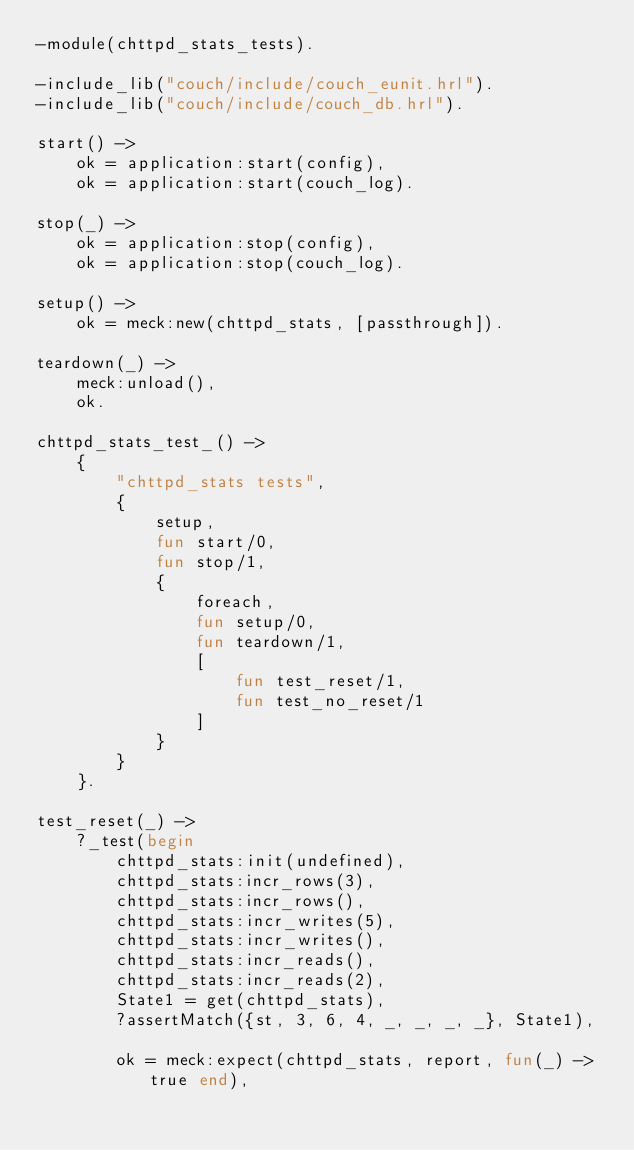Convert code to text. <code><loc_0><loc_0><loc_500><loc_500><_Erlang_>-module(chttpd_stats_tests).

-include_lib("couch/include/couch_eunit.hrl").
-include_lib("couch/include/couch_db.hrl").

start() ->
    ok = application:start(config),
    ok = application:start(couch_log).

stop(_) ->
    ok = application:stop(config),
    ok = application:stop(couch_log).

setup() ->
    ok = meck:new(chttpd_stats, [passthrough]).

teardown(_) ->
    meck:unload(),
    ok.

chttpd_stats_test_() ->
    {
        "chttpd_stats tests",
        {
            setup,
            fun start/0,
            fun stop/1,
            {
                foreach,
                fun setup/0,
                fun teardown/1,
                [
                    fun test_reset/1,
                    fun test_no_reset/1
                ]
            }
        }
    }.

test_reset(_) ->
    ?_test(begin
        chttpd_stats:init(undefined),
        chttpd_stats:incr_rows(3),
        chttpd_stats:incr_rows(),
        chttpd_stats:incr_writes(5),
        chttpd_stats:incr_writes(),
        chttpd_stats:incr_reads(),
        chttpd_stats:incr_reads(2),
        State1 = get(chttpd_stats),
        ?assertMatch({st, 3, 6, 4, _, _, _, _}, State1),

        ok = meck:expect(chttpd_stats, report, fun(_) -> true end),</code> 